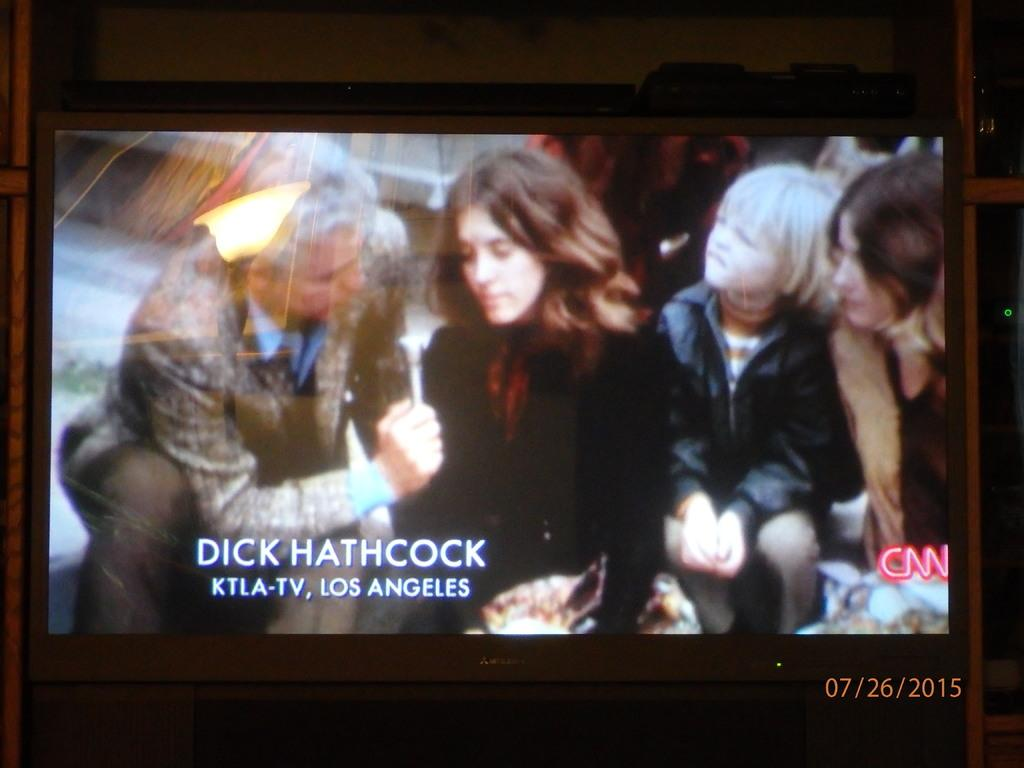<image>
Give a short and clear explanation of the subsequent image. A screen displays an interview labeled, "Dick Hathcock KTLA-TV, Los Angeles" on CNN. 